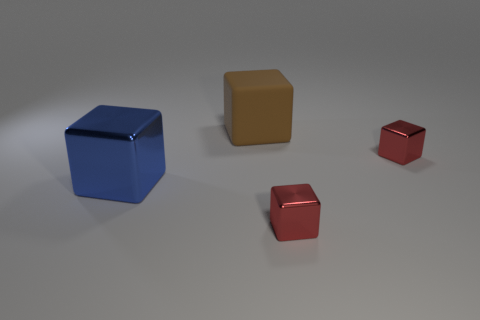Subtract all blue cubes. How many cubes are left? 3 Subtract 2 cubes. How many cubes are left? 2 Subtract all brown rubber cubes. How many cubes are left? 3 Subtract all gray cubes. Subtract all cyan cylinders. How many cubes are left? 4 Add 1 tiny red blocks. How many objects exist? 5 Add 1 tiny red shiny blocks. How many tiny red shiny blocks are left? 3 Add 4 big cyan rubber spheres. How many big cyan rubber spheres exist? 4 Subtract 1 blue blocks. How many objects are left? 3 Subtract all big blue metal blocks. Subtract all cyan metallic balls. How many objects are left? 3 